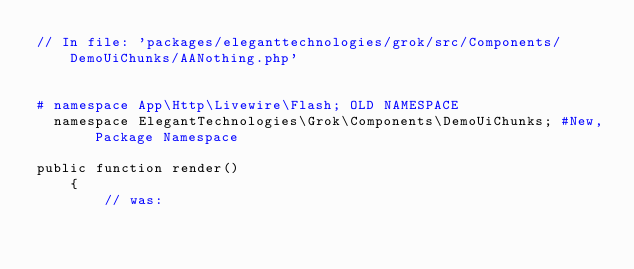Convert code to text. <code><loc_0><loc_0><loc_500><loc_500><_PHP_>// In file: 'packages/eleganttechnologies/grok/src/Components/DemoUiChunks/AANothing.php'


# namespace App\Http\Livewire\Flash; OLD NAMESPACE
  namespace ElegantTechnologies\Grok\Components\DemoUiChunks; #New, Package Namespace

public function render()
    {
        // was:</code> 